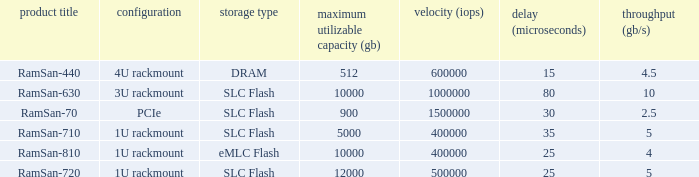What is the shape distortion for the range frequency of 10? 3U rackmount. 